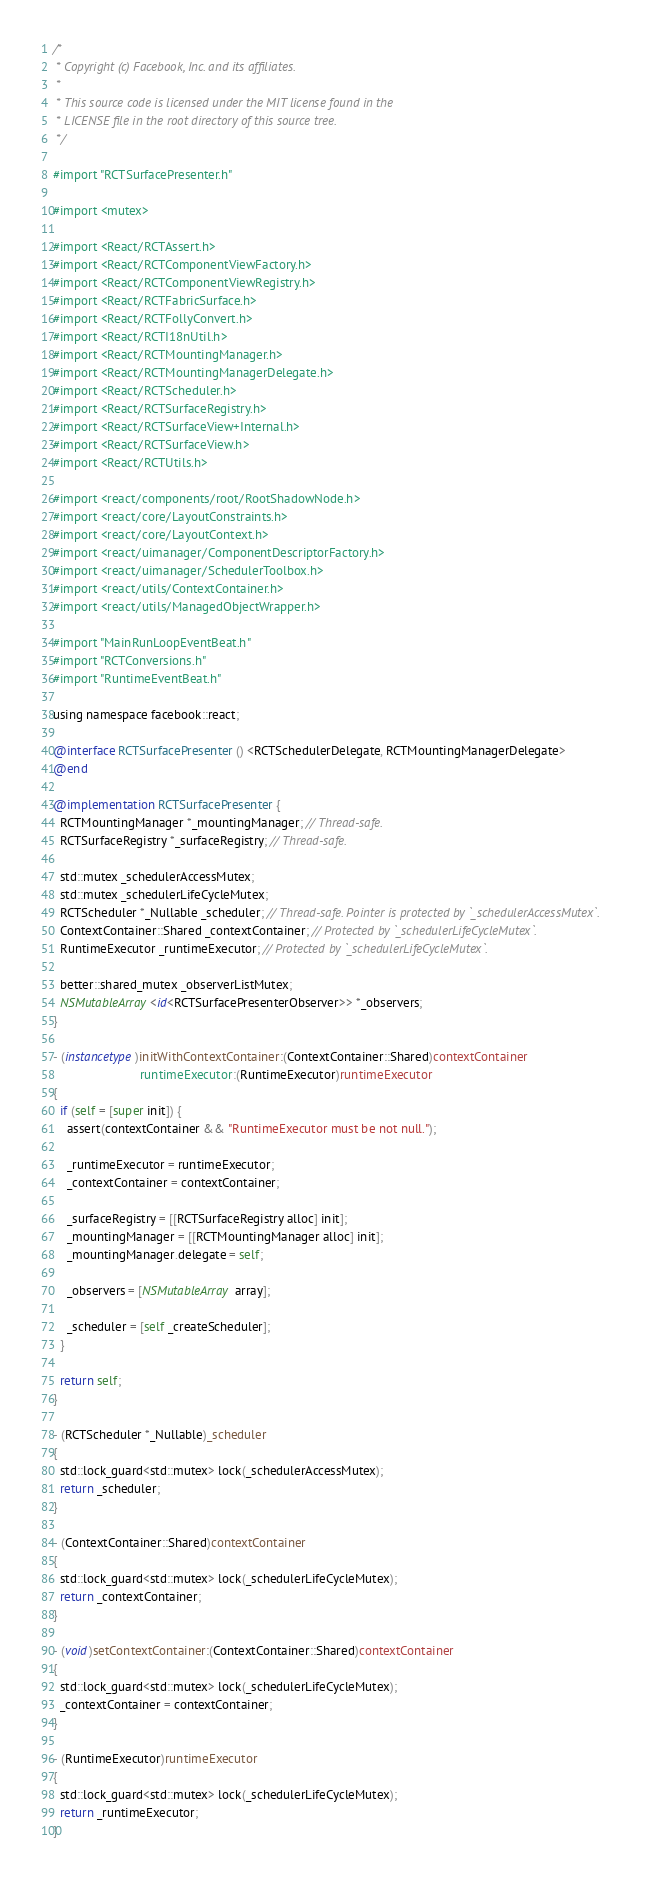Convert code to text. <code><loc_0><loc_0><loc_500><loc_500><_ObjectiveC_>/*
 * Copyright (c) Facebook, Inc. and its affiliates.
 *
 * This source code is licensed under the MIT license found in the
 * LICENSE file in the root directory of this source tree.
 */

#import "RCTSurfacePresenter.h"

#import <mutex>

#import <React/RCTAssert.h>
#import <React/RCTComponentViewFactory.h>
#import <React/RCTComponentViewRegistry.h>
#import <React/RCTFabricSurface.h>
#import <React/RCTFollyConvert.h>
#import <React/RCTI18nUtil.h>
#import <React/RCTMountingManager.h>
#import <React/RCTMountingManagerDelegate.h>
#import <React/RCTScheduler.h>
#import <React/RCTSurfaceRegistry.h>
#import <React/RCTSurfaceView+Internal.h>
#import <React/RCTSurfaceView.h>
#import <React/RCTUtils.h>

#import <react/components/root/RootShadowNode.h>
#import <react/core/LayoutConstraints.h>
#import <react/core/LayoutContext.h>
#import <react/uimanager/ComponentDescriptorFactory.h>
#import <react/uimanager/SchedulerToolbox.h>
#import <react/utils/ContextContainer.h>
#import <react/utils/ManagedObjectWrapper.h>

#import "MainRunLoopEventBeat.h"
#import "RCTConversions.h"
#import "RuntimeEventBeat.h"

using namespace facebook::react;

@interface RCTSurfacePresenter () <RCTSchedulerDelegate, RCTMountingManagerDelegate>
@end

@implementation RCTSurfacePresenter {
  RCTMountingManager *_mountingManager; // Thread-safe.
  RCTSurfaceRegistry *_surfaceRegistry; // Thread-safe.

  std::mutex _schedulerAccessMutex;
  std::mutex _schedulerLifeCycleMutex;
  RCTScheduler *_Nullable _scheduler; // Thread-safe. Pointer is protected by `_schedulerAccessMutex`.
  ContextContainer::Shared _contextContainer; // Protected by `_schedulerLifeCycleMutex`.
  RuntimeExecutor _runtimeExecutor; // Protected by `_schedulerLifeCycleMutex`.

  better::shared_mutex _observerListMutex;
  NSMutableArray<id<RCTSurfacePresenterObserver>> *_observers;
}

- (instancetype)initWithContextContainer:(ContextContainer::Shared)contextContainer
                         runtimeExecutor:(RuntimeExecutor)runtimeExecutor
{
  if (self = [super init]) {
    assert(contextContainer && "RuntimeExecutor must be not null.");

    _runtimeExecutor = runtimeExecutor;
    _contextContainer = contextContainer;

    _surfaceRegistry = [[RCTSurfaceRegistry alloc] init];
    _mountingManager = [[RCTMountingManager alloc] init];
    _mountingManager.delegate = self;

    _observers = [NSMutableArray array];

    _scheduler = [self _createScheduler];
  }

  return self;
}

- (RCTScheduler *_Nullable)_scheduler
{
  std::lock_guard<std::mutex> lock(_schedulerAccessMutex);
  return _scheduler;
}

- (ContextContainer::Shared)contextContainer
{
  std::lock_guard<std::mutex> lock(_schedulerLifeCycleMutex);
  return _contextContainer;
}

- (void)setContextContainer:(ContextContainer::Shared)contextContainer
{
  std::lock_guard<std::mutex> lock(_schedulerLifeCycleMutex);
  _contextContainer = contextContainer;
}

- (RuntimeExecutor)runtimeExecutor
{
  std::lock_guard<std::mutex> lock(_schedulerLifeCycleMutex);
  return _runtimeExecutor;
}
</code> 